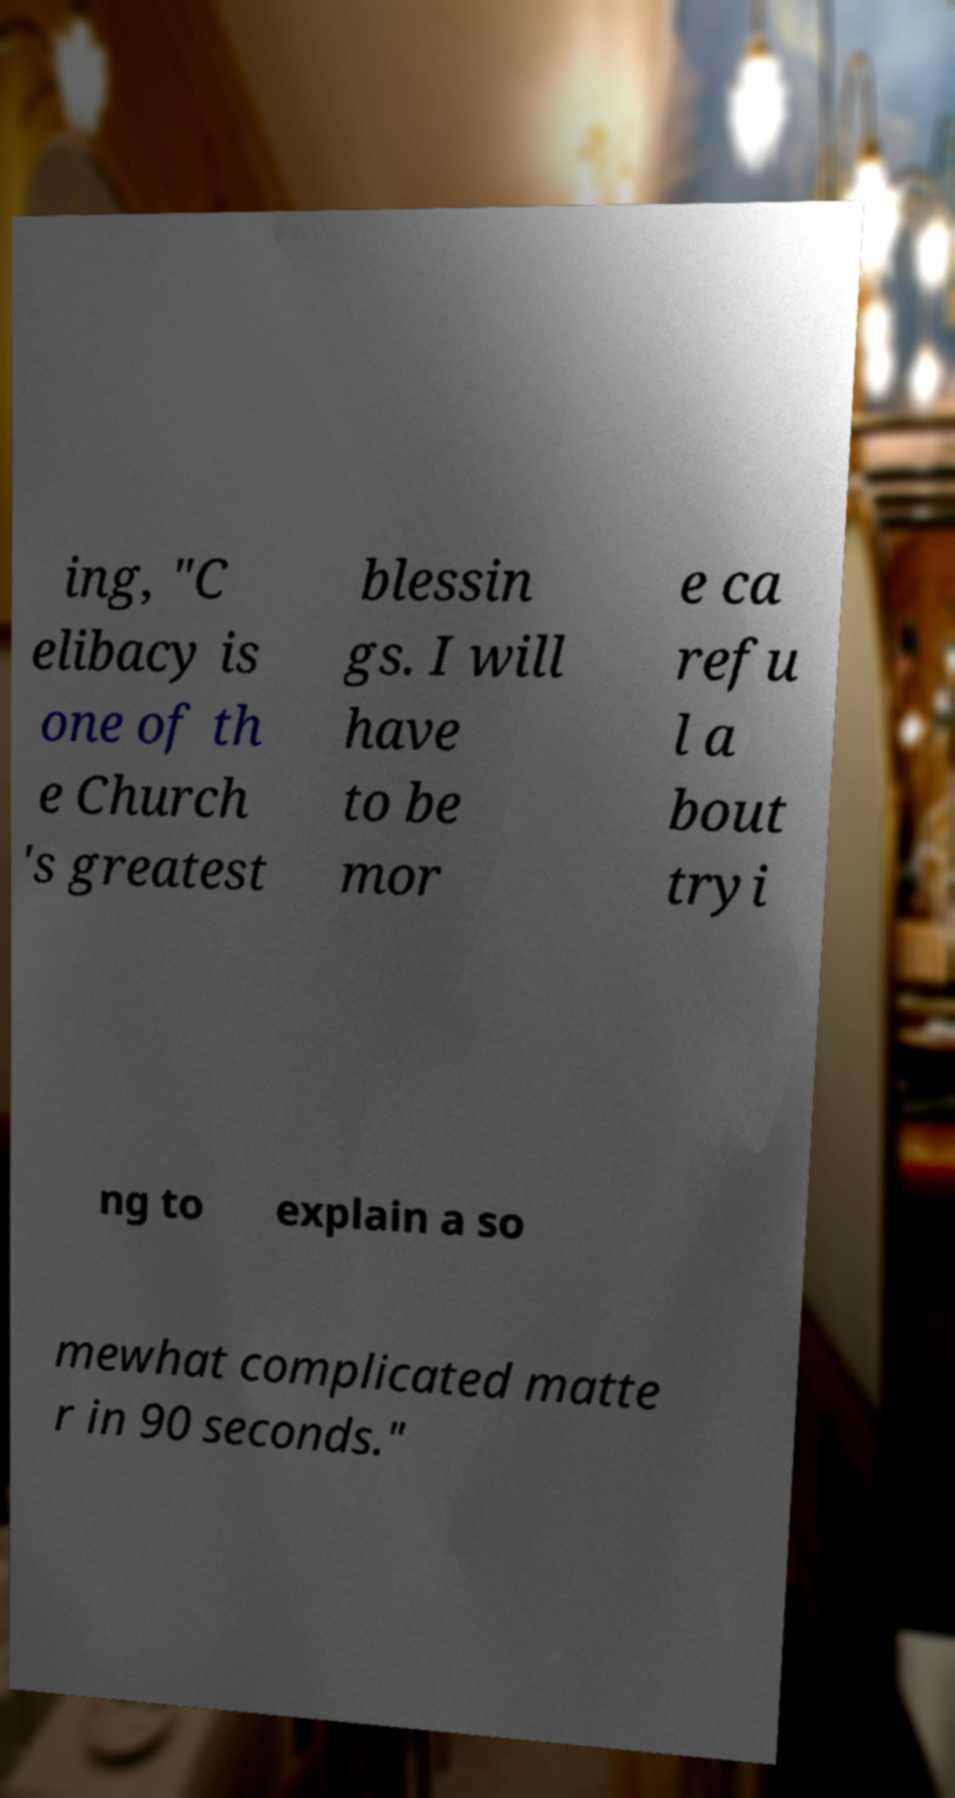Could you assist in decoding the text presented in this image and type it out clearly? ing, "C elibacy is one of th e Church 's greatest blessin gs. I will have to be mor e ca refu l a bout tryi ng to explain a so mewhat complicated matte r in 90 seconds." 